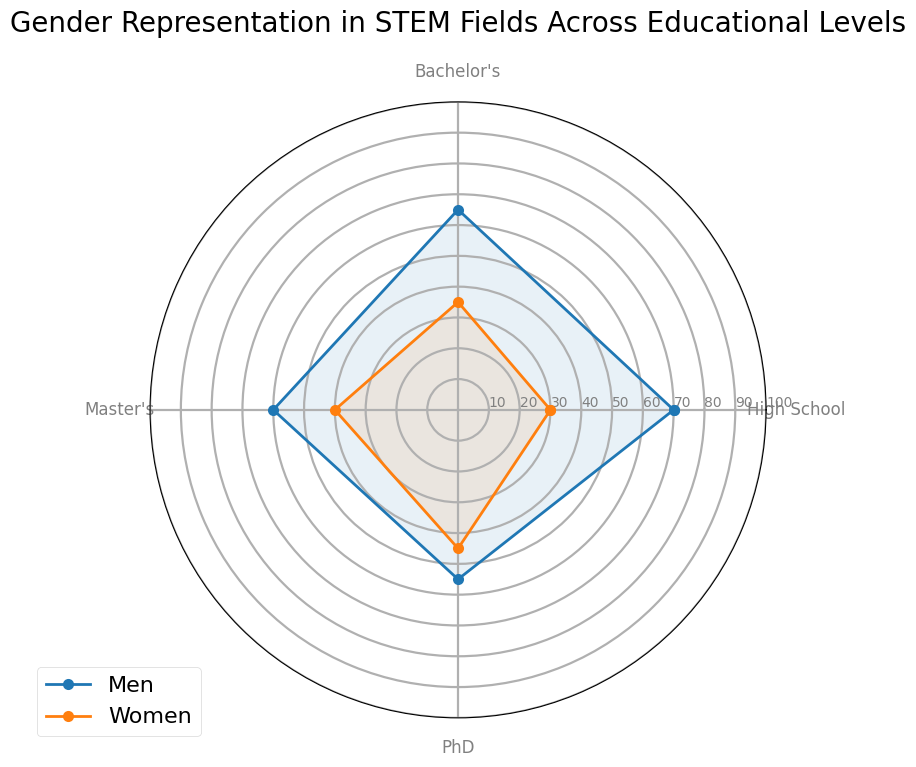What percentage of PhD students in STEM fields are women? The radar chart shows the percentage of women and men in different educational levels. To find the percentage of PhD students in STEM fields who are women, locate the value on the Women plot around the PhD axis.
Answer: 45% How do the percentages of men and women in Bachelor's compare? According to the radar chart, the percentage of men in Bachelor's level is 65% and for women, it is 35%. To compare, we see that the percentage of men in Bachelor's is higher than that of women.
Answer: Men have 65%, Women have 35% What is the average percentage of women across all educational levels? To find the average percentage of women across all educational levels, sum up the percentage values (30 for High School, 35 for Bachelor's, 40 for Master's, 45 for PhD) and divide by the number of levels (4). (30 + 35 + 40 + 45) / 4 = 37.5%
Answer: 37.5% Which educational level has the smallest gender gap in STEM fields? The radar chart shows the data for men and women across different educational levels. Calculate the absolute difference (gap) in percentages at each level: High School (70-30=40), Bachelor’s (65-35=30), Master’s (60-40=20), PhD (55-45=10). The smallest gap is at the PhD level.
Answer: PhD Are there more men or women pursuing Master's degrees in STEM fields? To determine the number of men versus women pursuing Master’s degrees, check the radar chart values. Men are at 60% and women at 40%. Therefore, there are more men.
Answer: Men Which gender shows an increasing trend in percentage from High School to PhD? Examine the radar chart trends for both men and women from High School to PhD. Men show a decreasing trend (70% to 55%), whereas women show an increasing trend (30% to 45%).
Answer: Women What is the combined percentage of men and women in STEM fields at the High School level? The combined percentage of men and women in any level should sum up to 100%. The radar chart confirms this, forming a closed loop at each level.
Answer: 100% Identify which level demonstrates the largest representation of women in STEM fields. To find the level with the largest women representation, inspect the Women data points on the radar chart across all educational levels. The highest value is at the PhD level with 45%.
Answer: PhD 